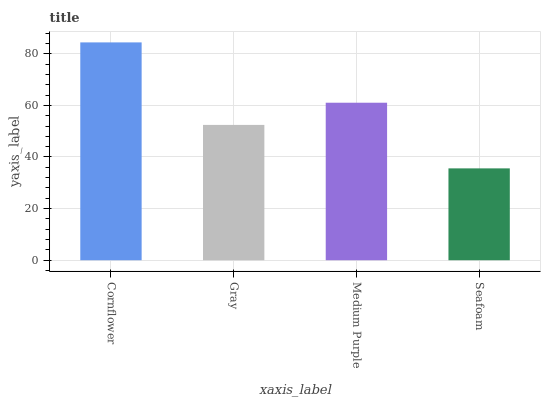Is Seafoam the minimum?
Answer yes or no. Yes. Is Cornflower the maximum?
Answer yes or no. Yes. Is Gray the minimum?
Answer yes or no. No. Is Gray the maximum?
Answer yes or no. No. Is Cornflower greater than Gray?
Answer yes or no. Yes. Is Gray less than Cornflower?
Answer yes or no. Yes. Is Gray greater than Cornflower?
Answer yes or no. No. Is Cornflower less than Gray?
Answer yes or no. No. Is Medium Purple the high median?
Answer yes or no. Yes. Is Gray the low median?
Answer yes or no. Yes. Is Seafoam the high median?
Answer yes or no. No. Is Medium Purple the low median?
Answer yes or no. No. 